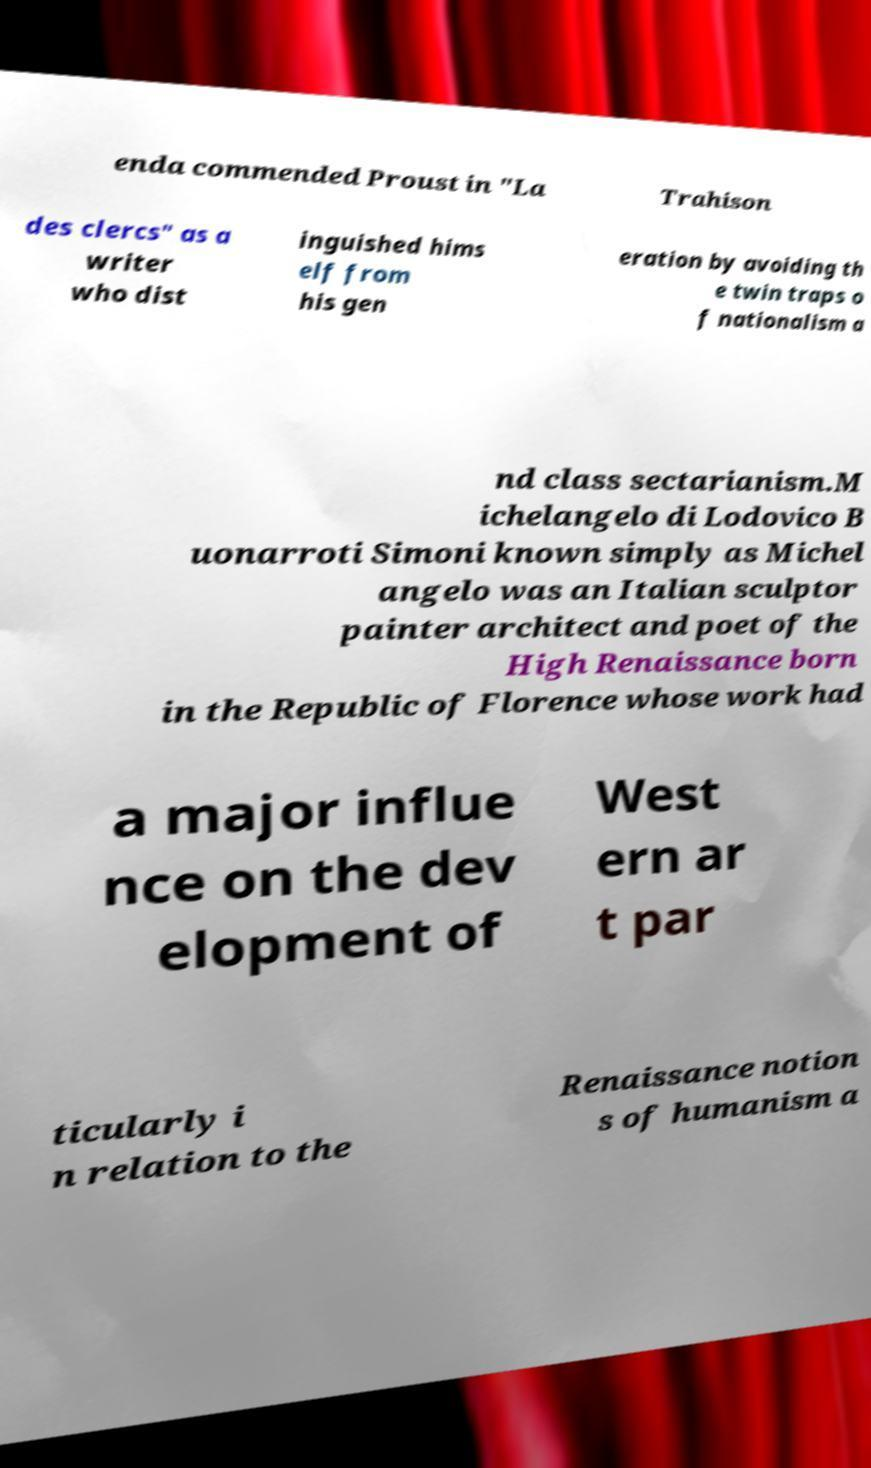Could you assist in decoding the text presented in this image and type it out clearly? enda commended Proust in "La Trahison des clercs" as a writer who dist inguished hims elf from his gen eration by avoiding th e twin traps o f nationalism a nd class sectarianism.M ichelangelo di Lodovico B uonarroti Simoni known simply as Michel angelo was an Italian sculptor painter architect and poet of the High Renaissance born in the Republic of Florence whose work had a major influe nce on the dev elopment of West ern ar t par ticularly i n relation to the Renaissance notion s of humanism a 